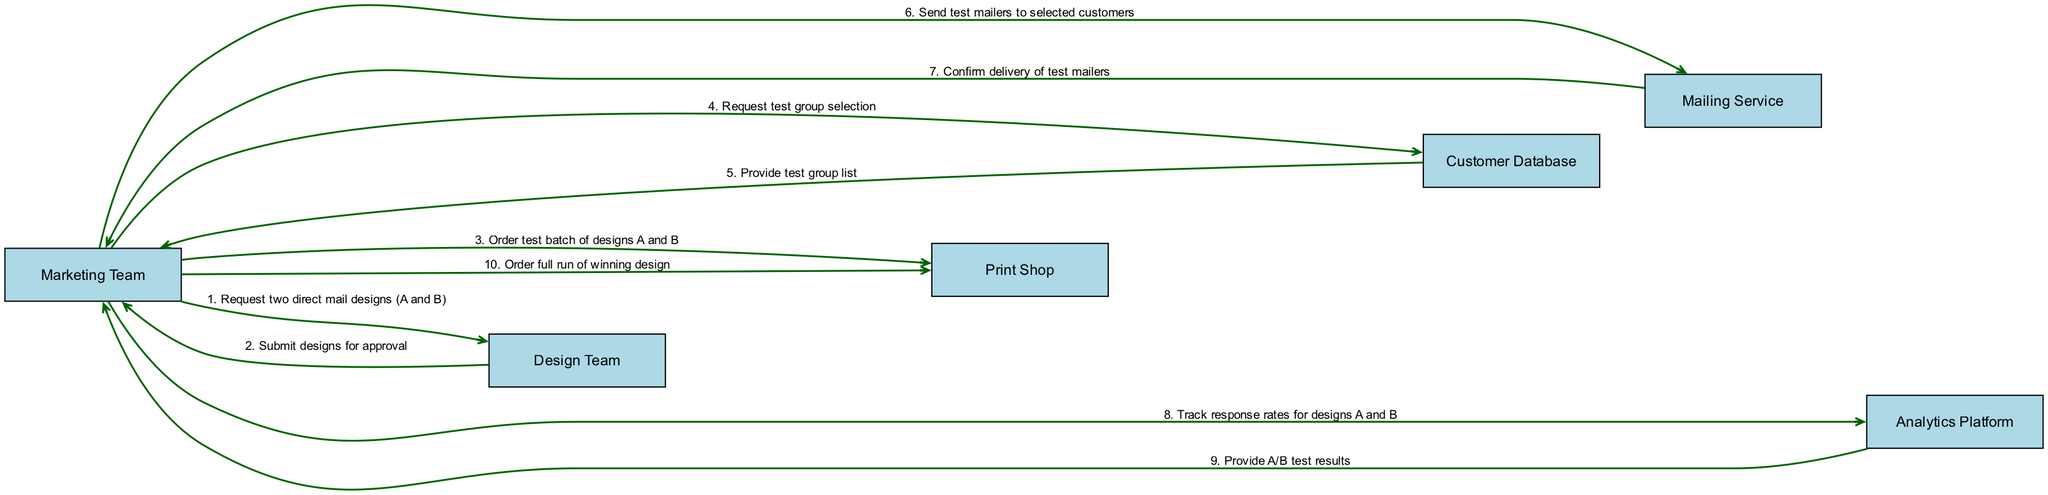what are the participants in the sequence diagram? The diagram includes the following participants: Marketing Team, Design Team, Print Shop, Customer Database, Mailing Service, and Analytics Platform. These are depicted as boxes in the sequence diagram.
Answer: Marketing Team, Design Team, Print Shop, Customer Database, Mailing Service, Analytics Platform how many messages are exchanged in the sequence diagram? By reviewing the sequence of events in the diagram, we can count the number of messages. There are ten messages exchanged between the participants.
Answer: 10 who initiates the request for test group selection? The sequence indicates that the Marketing Team sends a message to the Customer Database to request test group selection. This flow shows the Marketing Team's role as the initiator of this request.
Answer: Marketing Team which team orders the full run of the winning design? The last message in the sequence diagram shows that the Marketing Team is the entity that orders the full run of the winning design, following the test results.
Answer: Marketing Team what is the first action taken in this A/B testing process? The first action in the sequence diagram is the Marketing Team requesting two direct mail designs (A and B) from the Design Team. This initiates the entire testing process.
Answer: Request two direct mail designs (A and B) what confirmation does the Mailing Service provide? According to the flow of events, after sending the test mailers, the Mailing Service confirms the delivery of those mailers back to the Marketing Team. This confirmation is key for the Marketing Team to proceed.
Answer: Confirm delivery of test mailers how does the Marketing Team track the performance of the designs? The sequence shows that the Marketing Team tracks response rates for designs A and B by communicating with the Analytics Platform, which is part of the process to evaluate the success of the designs.
Answer: Track response rates for designs A and B which teams are involved in the design approval phase? The sequence indicates that the Marketing Team and Design Team are involved in the design approval phase, where the Marketing Team awaits the designs' submission for approval from the Design Team.
Answer: Marketing Team, Design Team what does the Analytics Platform provide to the Marketing Team? Following the analysis of the test results, the Analytics Platform provides the A/B test results to the Marketing Team, which is crucial for determining the winning design.
Answer: Provide A/B test results 